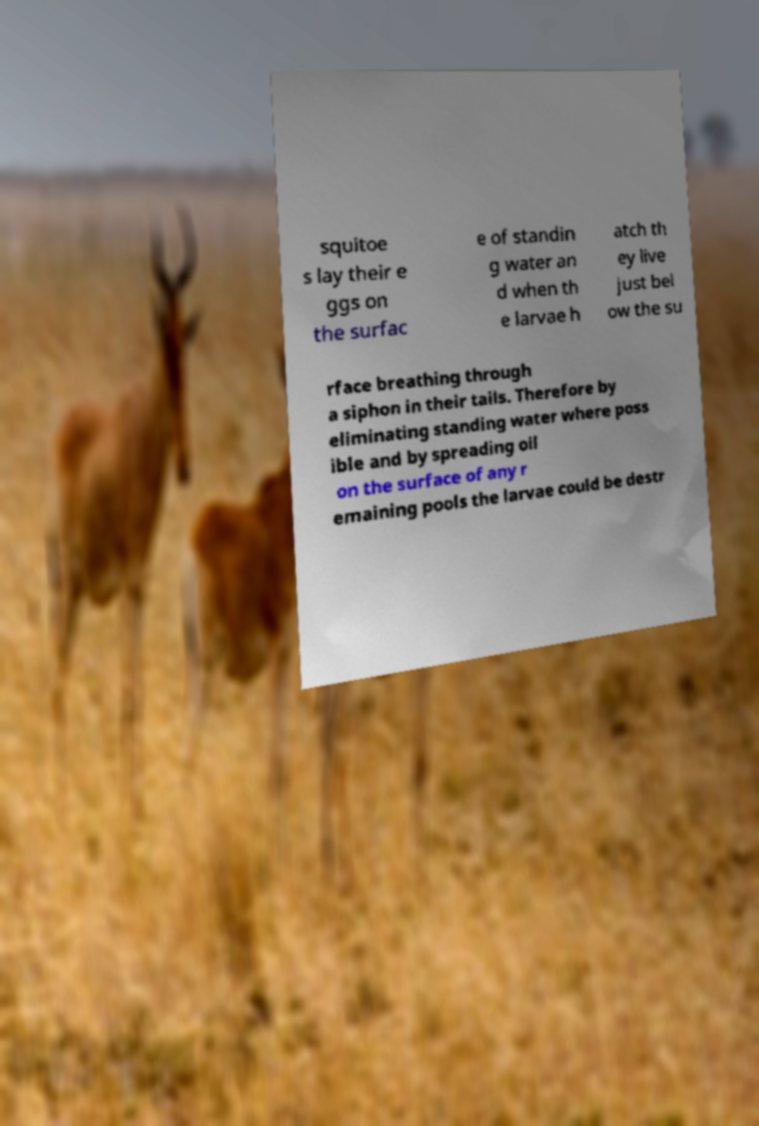Could you extract and type out the text from this image? squitoe s lay their e ggs on the surfac e of standin g water an d when th e larvae h atch th ey live just bel ow the su rface breathing through a siphon in their tails. Therefore by eliminating standing water where poss ible and by spreading oil on the surface of any r emaining pools the larvae could be destr 